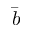Convert formula to latex. <formula><loc_0><loc_0><loc_500><loc_500>\bar { b }</formula> 